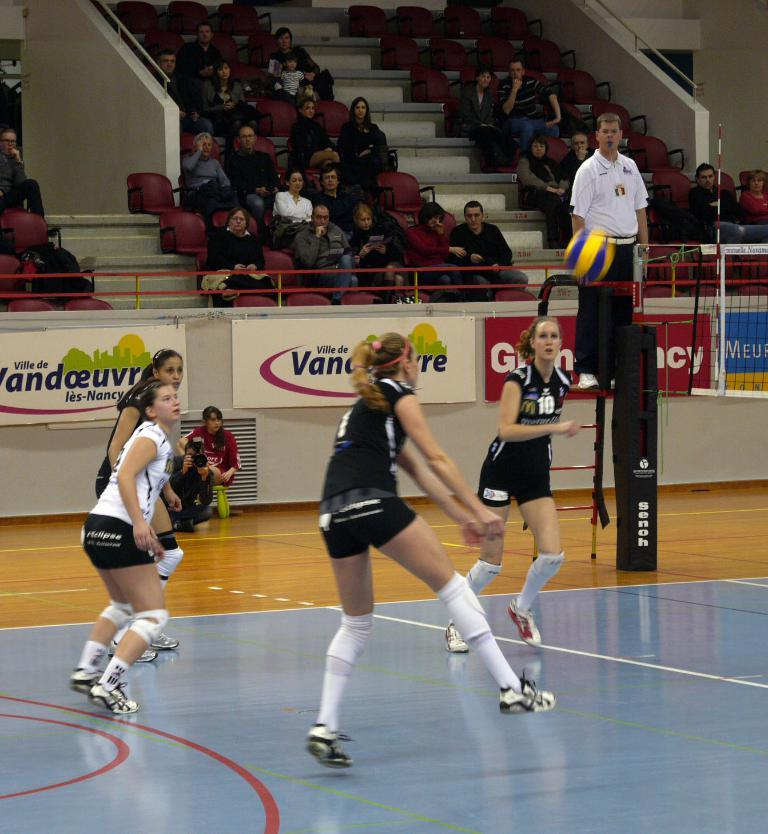What is happening in the image involving the players? There are players in the image, which suggests some form of activity or game is taking place. What can be seen in the background of the image? There are people sitting on chairs in the background. What object is present in the image that is commonly used in games or sports? There is a ball in the image. What architectural feature is visible in the image? There are stairs in the image. What is used to separate the two sides or teams in the game? There is a net in the image. What additional decorative elements are present in the image? There are banners attached to the fencing in the image. How many balloons are being used by the players in the image? There are no balloons present in the image; it features players, a ball, and other game-related elements. What message is written on the good-bye banner in the image? There is no good-bye banner present in the image; it features banners with unspecified messages attached to the fencing. 